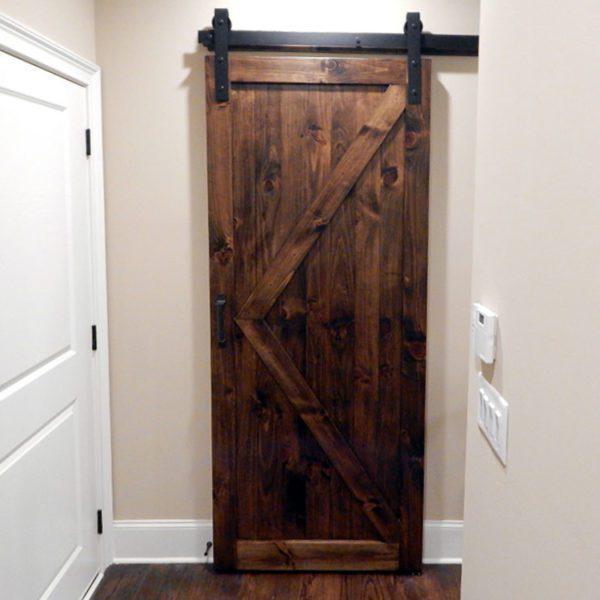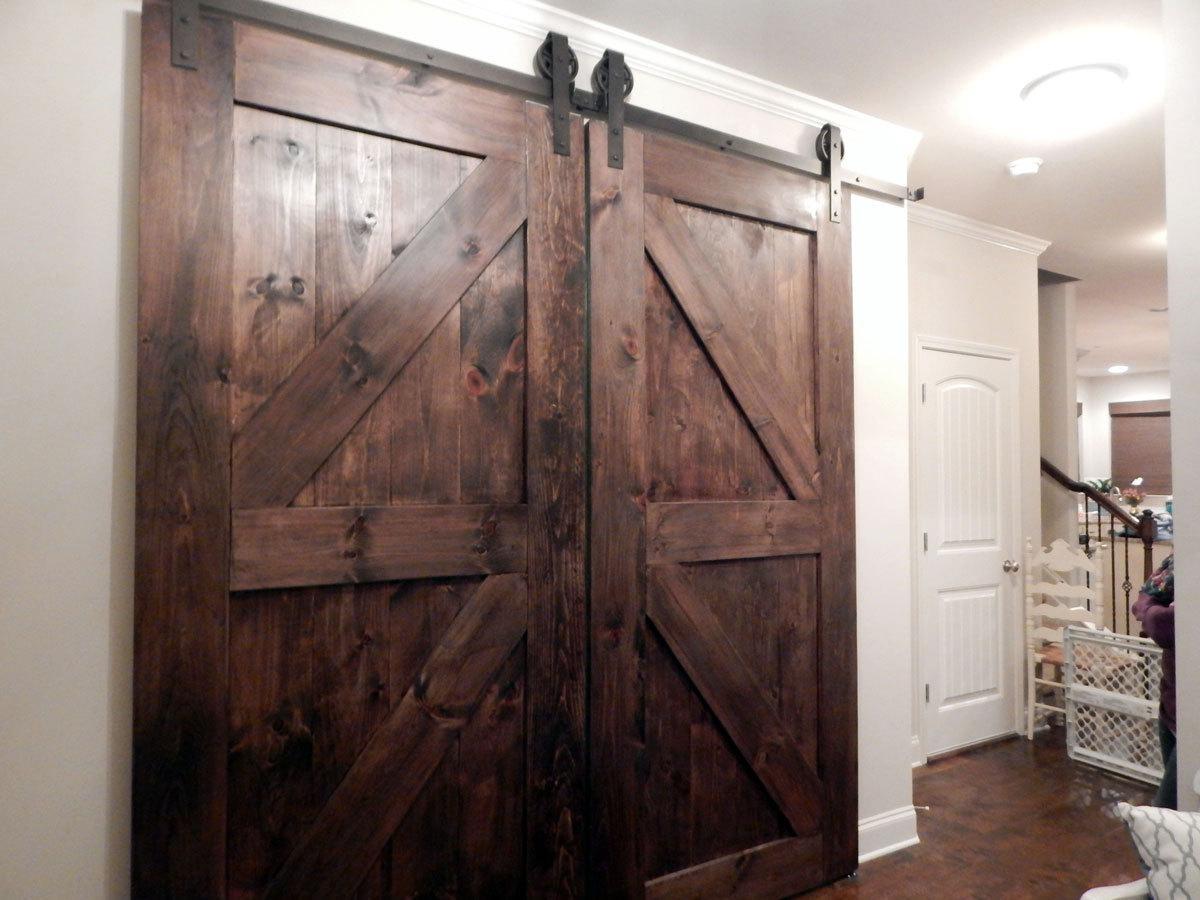The first image is the image on the left, the second image is the image on the right. Analyze the images presented: Is the assertion "All the sliding doors are solid wood." valid? Answer yes or no. Yes. The first image is the image on the left, the second image is the image on the right. Considering the images on both sides, is "There are three hanging doors." valid? Answer yes or no. Yes. 